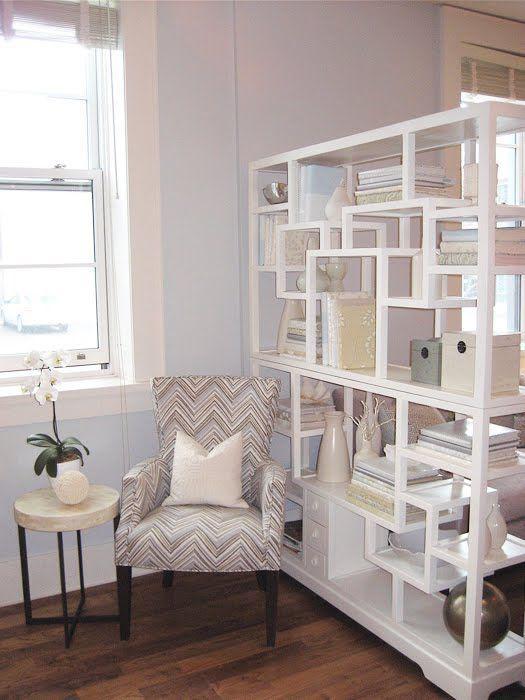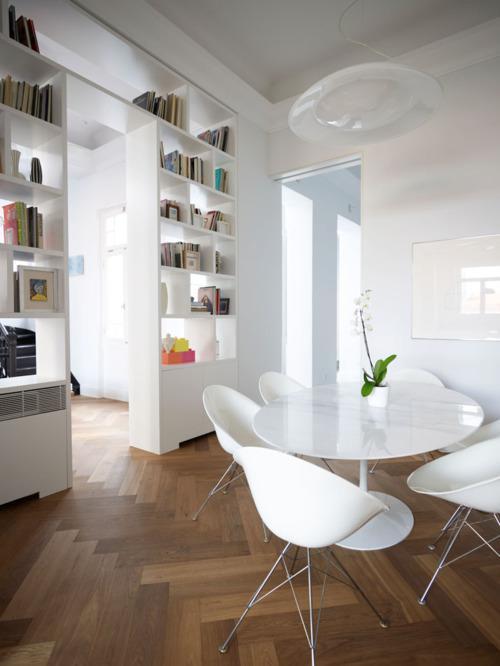The first image is the image on the left, the second image is the image on the right. Considering the images on both sides, is "In at least one image, a shelving unit is used as a room divider." valid? Answer yes or no. Yes. The first image is the image on the left, the second image is the image on the right. For the images displayed, is the sentence "there is a chair in the image on the left" factually correct? Answer yes or no. Yes. 